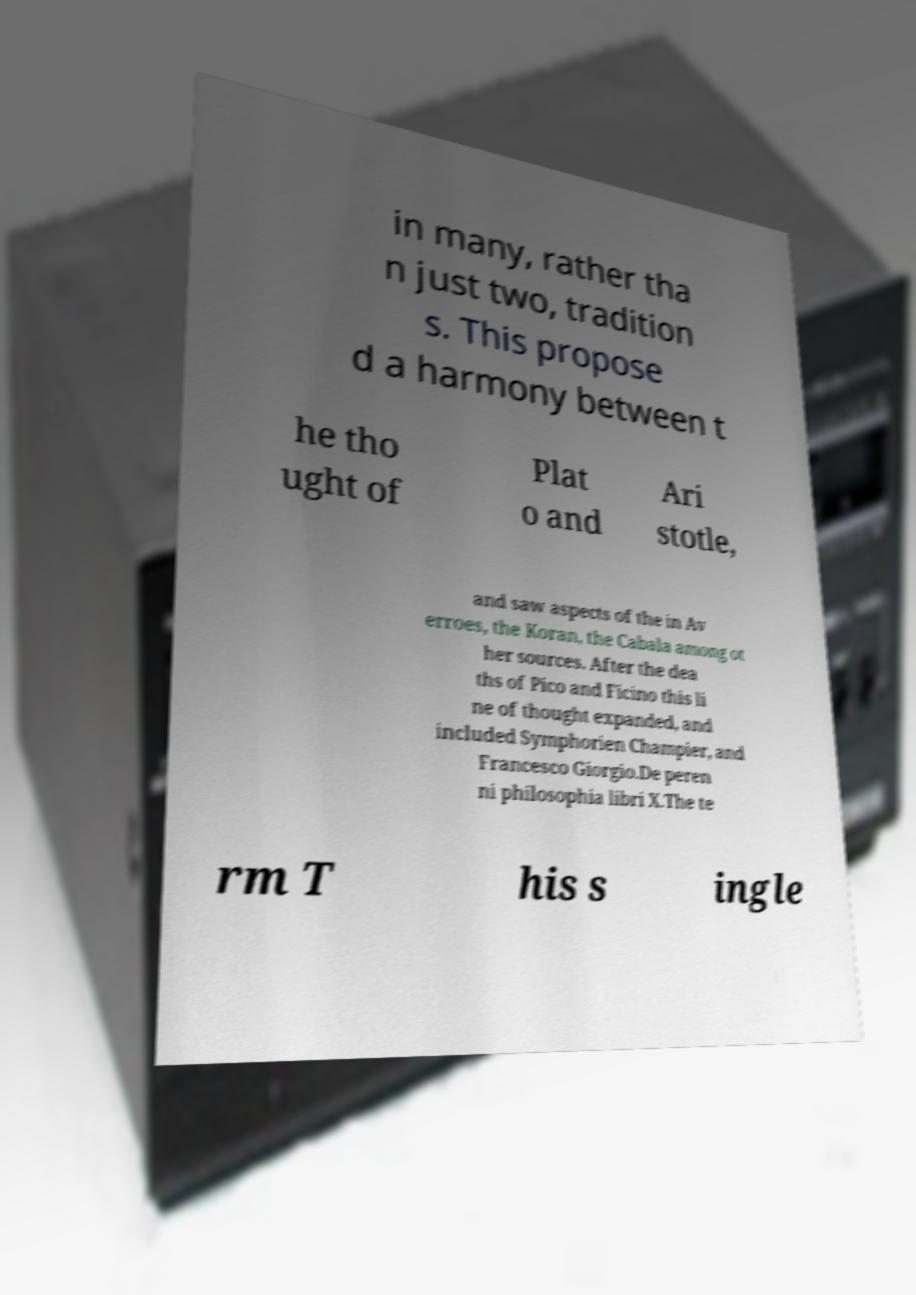Please read and relay the text visible in this image. What does it say? in many, rather tha n just two, tradition s. This propose d a harmony between t he tho ught of Plat o and Ari stotle, and saw aspects of the in Av erroes, the Koran, the Cabala among ot her sources. After the dea ths of Pico and Ficino this li ne of thought expanded, and included Symphorien Champier, and Francesco Giorgio.De peren ni philosophia libri X.The te rm T his s ingle 